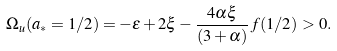Convert formula to latex. <formula><loc_0><loc_0><loc_500><loc_500>\Omega _ { u } ( { a _ { * } = 1 / 2 } ) = - \varepsilon + 2 \xi - \frac { 4 \alpha \xi } { ( 3 + \alpha ) } \, f ( 1 / 2 ) > 0 .</formula> 